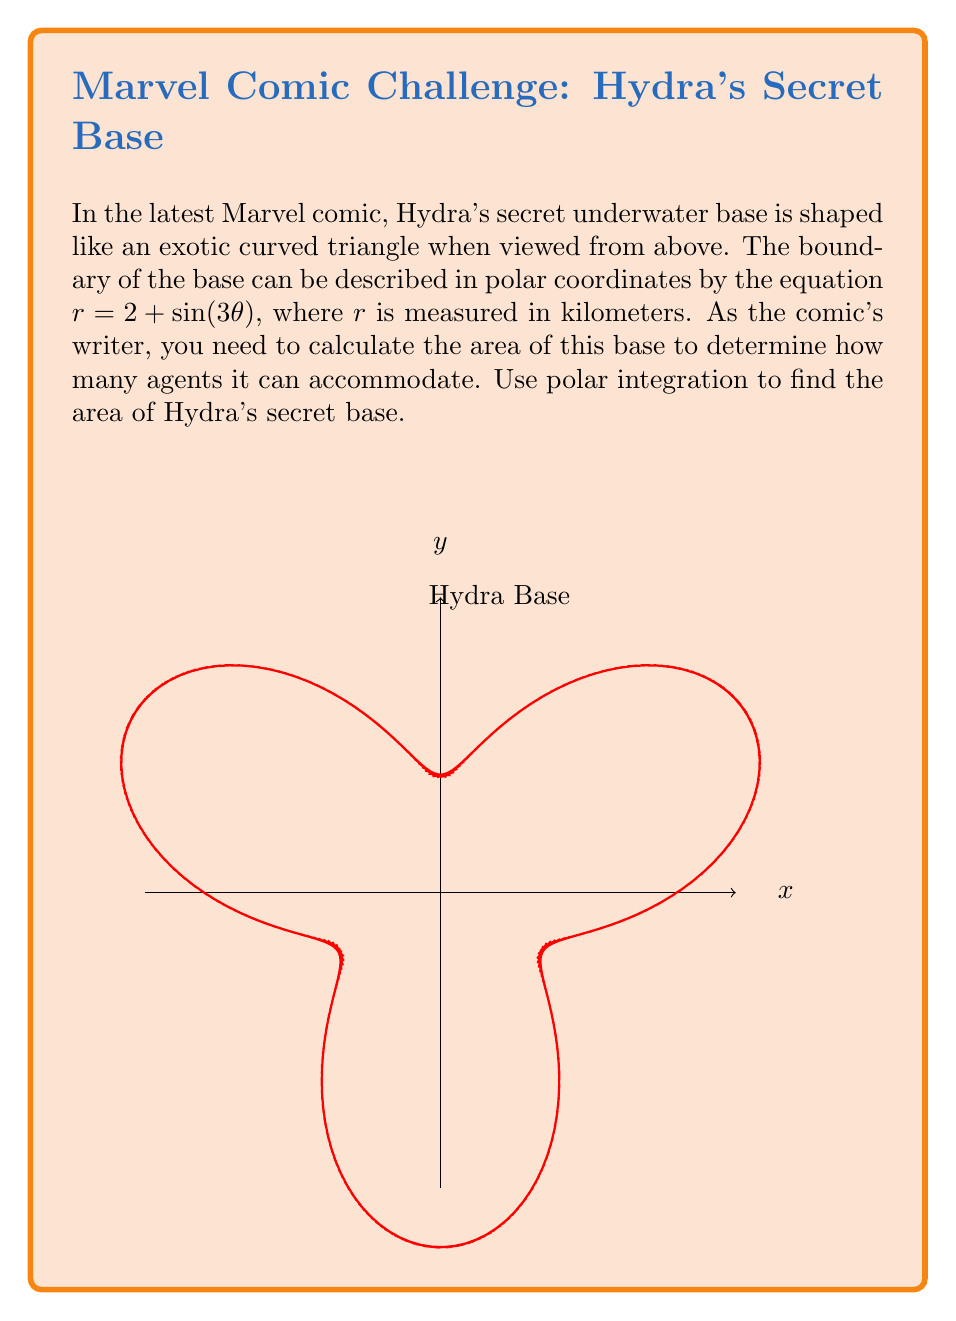Solve this math problem. To calculate the area of the region described by a polar equation, we use the formula:

$$A = \frac{1}{2} \int_{0}^{2\pi} r^2(\theta) d\theta$$

Here, $r(\theta) = 2 + \sin(3\theta)$

Step 1: Square the radius function
$$r^2(\theta) = (2 + \sin(3\theta))^2 = 4 + 4\sin(3\theta) + \sin^2(3\theta)$$

Step 2: Set up the integral
$$A = \frac{1}{2} \int_{0}^{2\pi} (4 + 4\sin(3\theta) + \sin^2(3\theta)) d\theta$$

Step 3: Integrate each term
- $\int_{0}^{2\pi} 4 d\theta = 4\theta \big|_{0}^{2\pi} = 8\pi$
- $\int_{0}^{2\pi} 4\sin(3\theta) d\theta = -\frac{4}{3}\cos(3\theta) \big|_{0}^{2\pi} = 0$
- $\int_{0}^{2\pi} \sin^2(3\theta) d\theta = \int_{0}^{2\pi} \frac{1-\cos(6\theta)}{2} d\theta = \frac{\theta}{2} - \frac{\sin(6\theta)}{12} \big|_{0}^{2\pi} = \pi$

Step 4: Sum up the results
$$A = \frac{1}{2} (8\pi + 0 + \pi) = \frac{9\pi}{2}$$

Step 5: The area is in square kilometers, so we need to state the units in the final answer.
Answer: $\frac{9\pi}{2}$ km² 